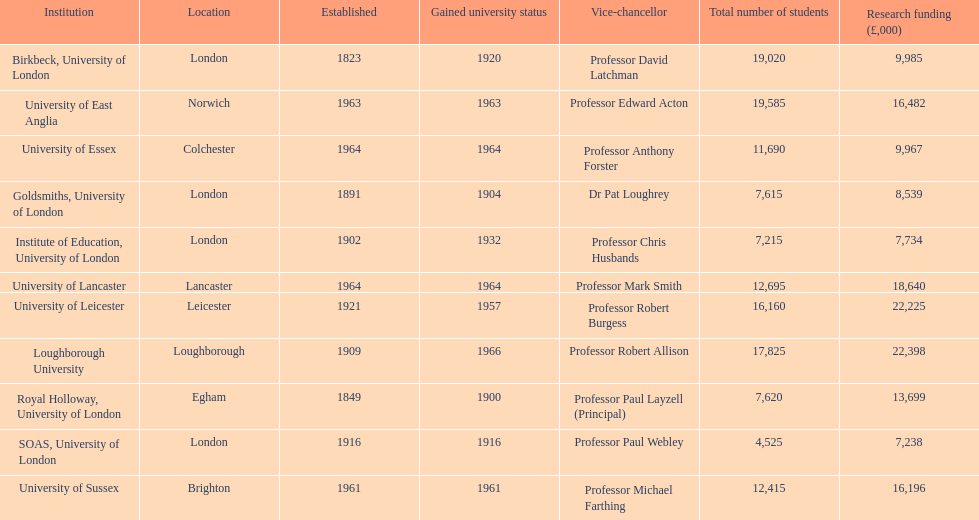Which establishment is granted the largest sum of money for research purposes? Loughborough University. 